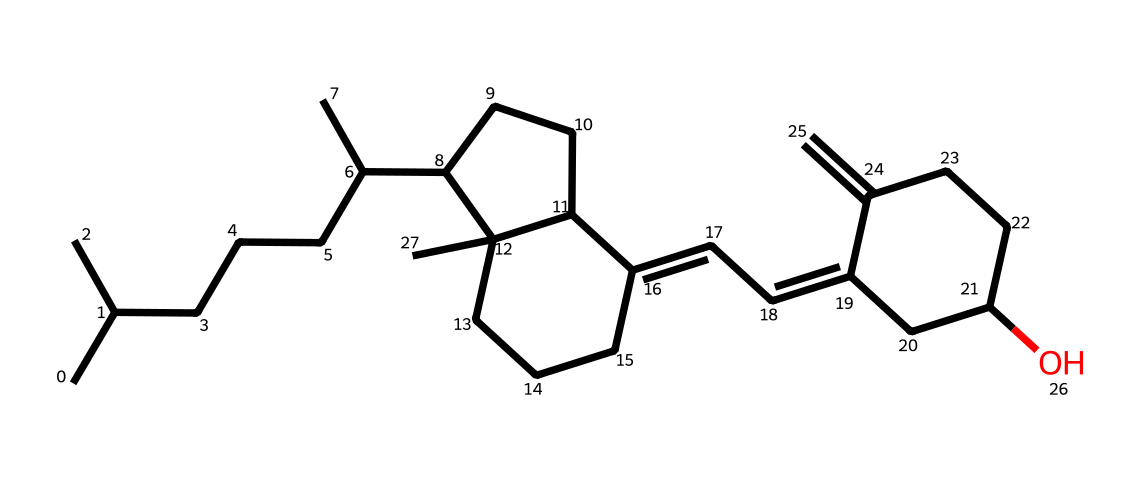how many carbon atoms are in this vitamin D structure? By examining the provided SMILES representation, each carbon atom can be counted based on the chain and branching, leading to a total count. There are 27 carbon atoms in the chemical structure represented.
Answer: 27 what is the functional group present in this vitamin D molecule? A careful observation of the structure shows the presence of a hydroxyl group (-OH), indicating that this molecule contains a functional group characteristic of alcohols.
Answer: hydroxyl is this structure likely to be hydrophobic or hydrophilic? The long hydrocarbon chains and the presence of only one hydroxyl group suggest that the molecule is mostly non-polar, which means it would be hydrophobic.
Answer: hydrophobic what is the core structure type of this vitamin D molecule? The chemical structure indicates a steroid core, characterized by fused ring structure commonly found in steroids and some vitamins.
Answer: steroid how many double bonds are present in the vitamin D structure? By analyzing the connections in the SMILES string, you can identify the locations of double bonds. There are three double bonds present in the structure.
Answer: 3 which vitamin does this structure represent? This molecular structure is well-known as vitamin D, specifically vitamin D2 or D3 series based on its configuration and synthesis pathway.
Answer: vitamin D 